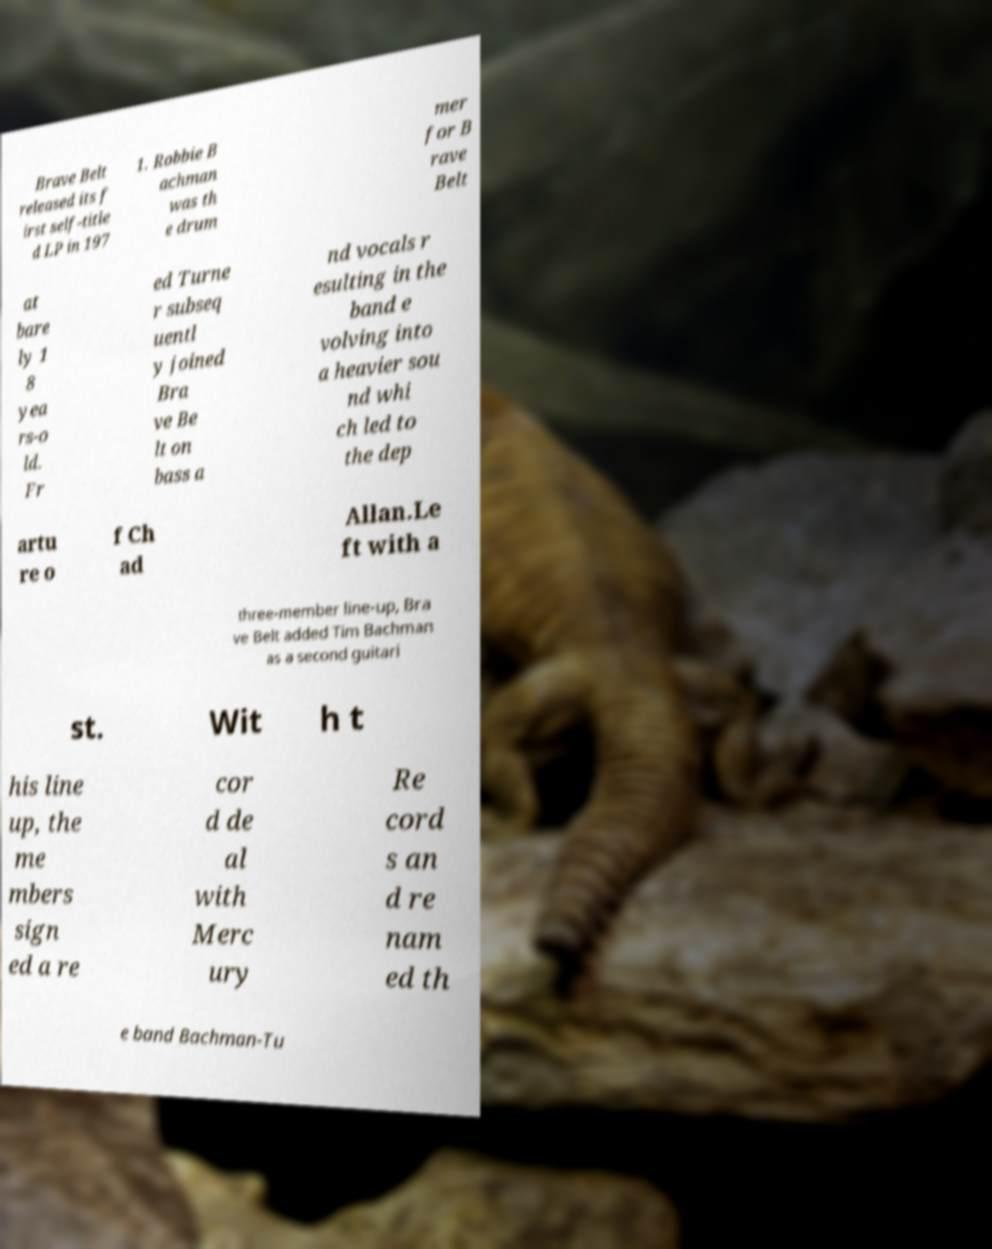Could you assist in decoding the text presented in this image and type it out clearly? Brave Belt released its f irst self-title d LP in 197 1. Robbie B achman was th e drum mer for B rave Belt at bare ly 1 8 yea rs-o ld. Fr ed Turne r subseq uentl y joined Bra ve Be lt on bass a nd vocals r esulting in the band e volving into a heavier sou nd whi ch led to the dep artu re o f Ch ad Allan.Le ft with a three-member line-up, Bra ve Belt added Tim Bachman as a second guitari st. Wit h t his line up, the me mbers sign ed a re cor d de al with Merc ury Re cord s an d re nam ed th e band Bachman-Tu 